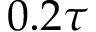<formula> <loc_0><loc_0><loc_500><loc_500>0 . 2 \tau</formula> 